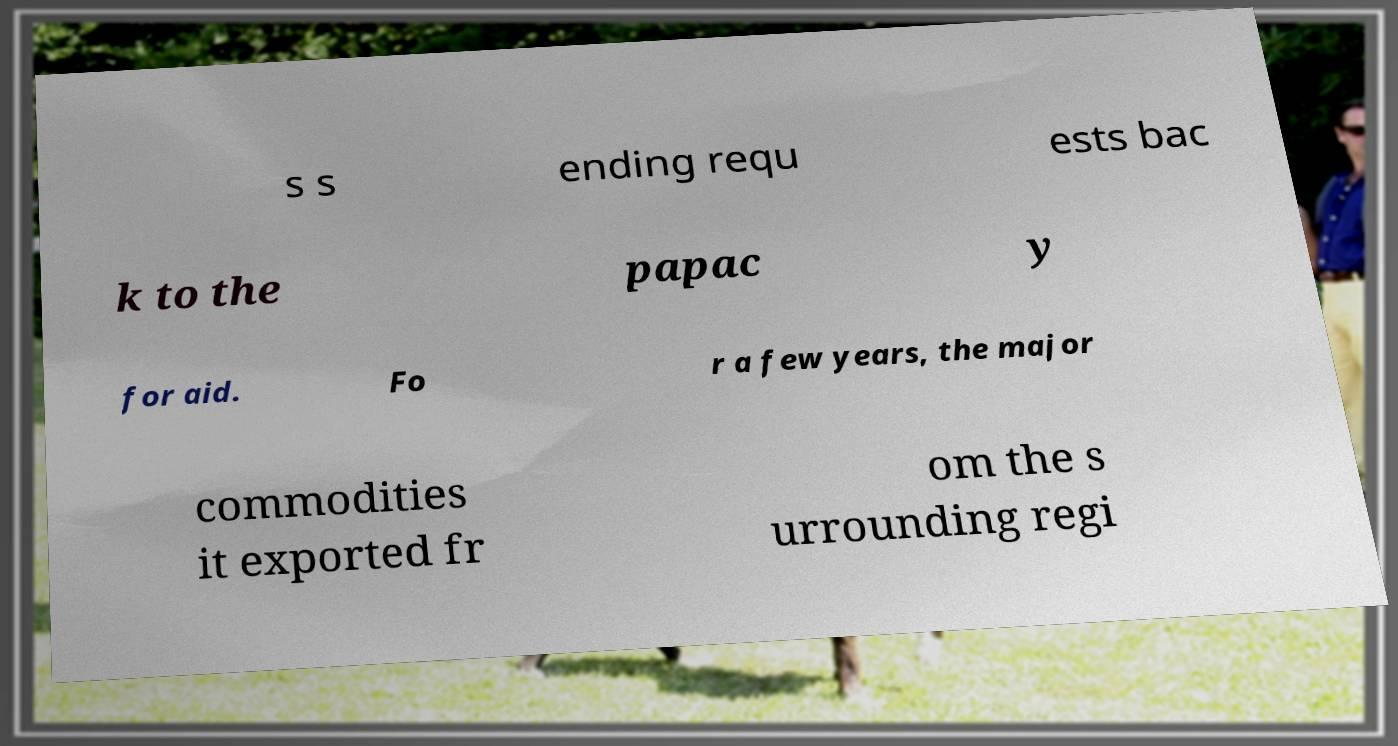Can you read and provide the text displayed in the image?This photo seems to have some interesting text. Can you extract and type it out for me? s s ending requ ests bac k to the papac y for aid. Fo r a few years, the major commodities it exported fr om the s urrounding regi 